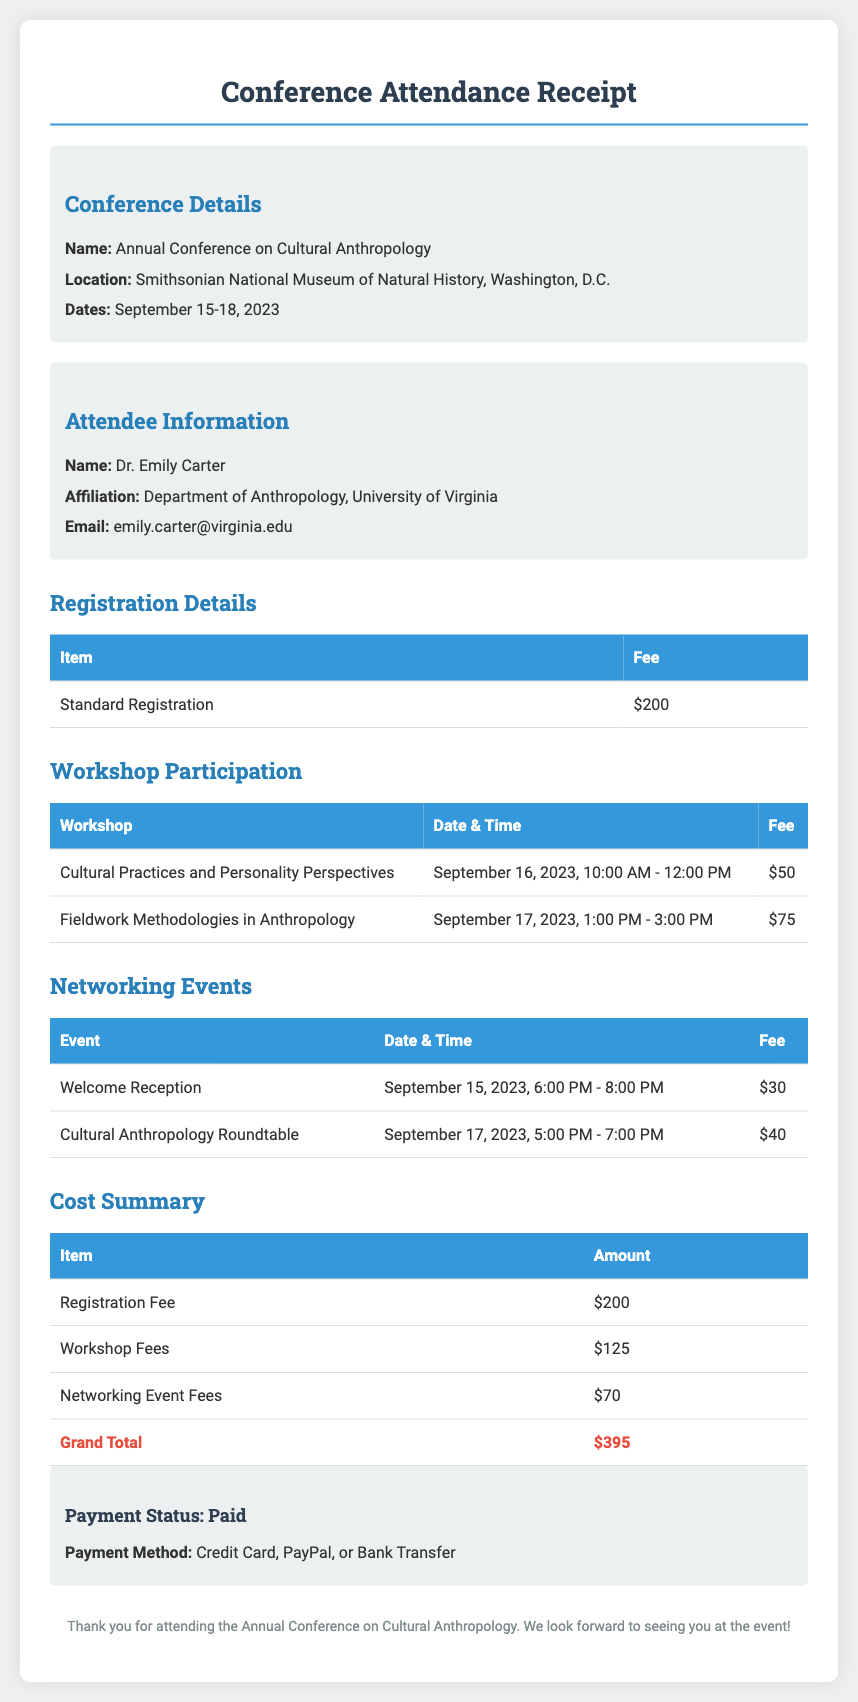What is the name of the conference? The name of the conference is specified in the document under Conference Details.
Answer: Annual Conference on Cultural Anthropology What was the total cost for workshop participation? The total cost for workshop participation is calculated from the individual workshop fees listed.
Answer: $125 What is the date of the Welcome Reception? The date is provided in the Networking Events section of the document.
Answer: September 15, 2023 Who is the attendee of the conference? The document provides the name of the attendee in the Attendee Information section.
Answer: Dr. Emily Carter How much was paid for the Cultural Practices and Personality Perspectives workshop? The fee for the specified workshop is listed in the Workshop Participation table.
Answer: $50 What is the location of the conference? The location is stated in the Conference Details section of the document.
Answer: Smithsonian National Museum of Natural History, Washington, D.C What is the payment status? The payment status is indicated in the Cost Summary section.
Answer: Paid What is the total amount paid? The total amount is summarized in the Cost Summary table under Grand Total.
Answer: $395 